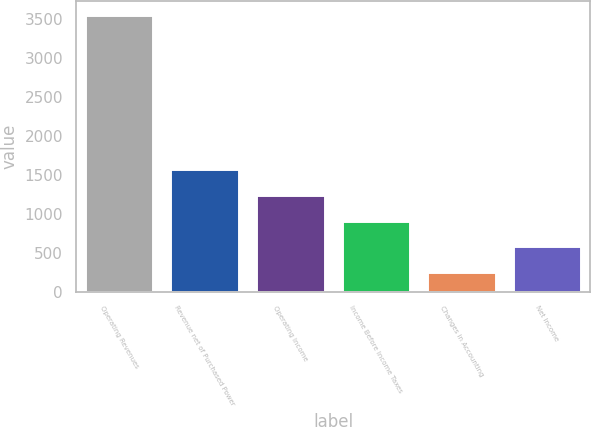<chart> <loc_0><loc_0><loc_500><loc_500><bar_chart><fcel>Operating Revenues<fcel>Revenue net of Purchased Power<fcel>Operating Income<fcel>Income Before Income Taxes<fcel>Changes in Accounting<fcel>Net Income<nl><fcel>3552<fcel>1572<fcel>1242<fcel>912<fcel>252<fcel>582<nl></chart> 